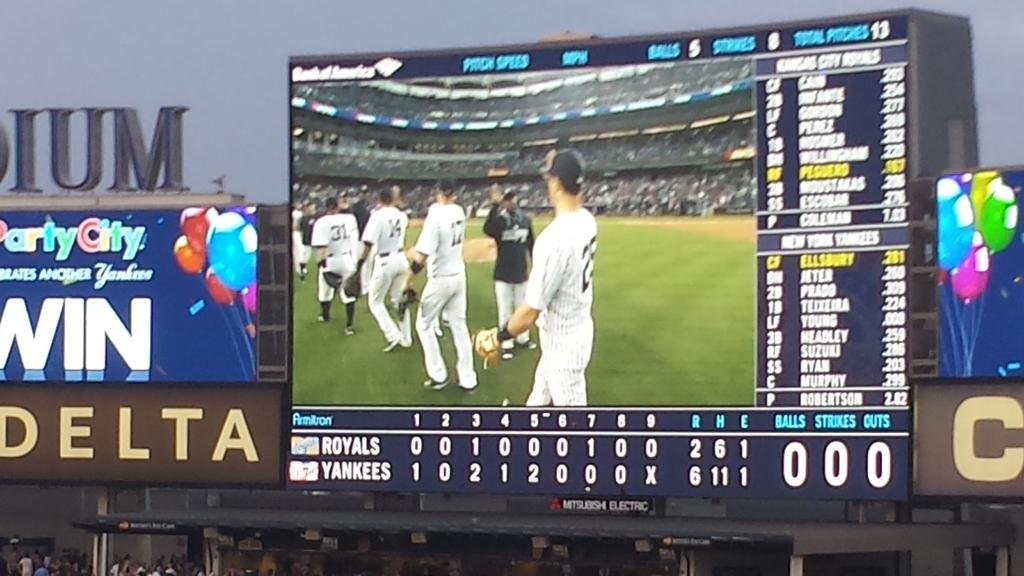<image>
Present a compact description of the photo's key features. A Delta sign is displayed next to the large score board. 